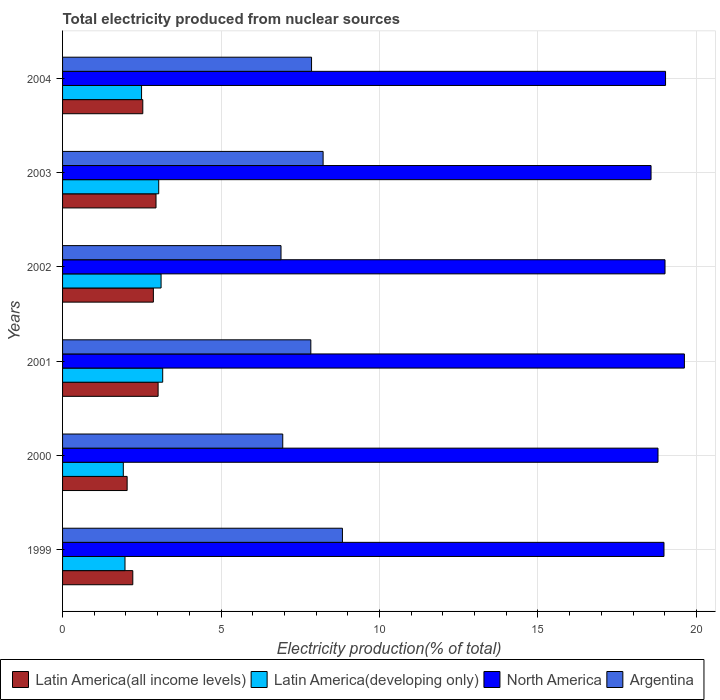How many groups of bars are there?
Make the answer very short. 6. Are the number of bars on each tick of the Y-axis equal?
Give a very brief answer. Yes. How many bars are there on the 5th tick from the bottom?
Make the answer very short. 4. What is the label of the 2nd group of bars from the top?
Your answer should be compact. 2003. In how many cases, is the number of bars for a given year not equal to the number of legend labels?
Offer a very short reply. 0. What is the total electricity produced in Latin America(developing only) in 2004?
Give a very brief answer. 2.49. Across all years, what is the maximum total electricity produced in Latin America(all income levels)?
Ensure brevity in your answer.  3.01. Across all years, what is the minimum total electricity produced in North America?
Offer a terse response. 18.57. What is the total total electricity produced in Latin America(developing only) in the graph?
Keep it short and to the point. 15.68. What is the difference between the total electricity produced in Latin America(all income levels) in 2000 and that in 2003?
Your response must be concise. -0.91. What is the difference between the total electricity produced in Latin America(all income levels) in 2000 and the total electricity produced in Argentina in 1999?
Offer a terse response. -6.79. What is the average total electricity produced in Latin America(all income levels) per year?
Ensure brevity in your answer.  2.6. In the year 2003, what is the difference between the total electricity produced in Argentina and total electricity produced in Latin America(all income levels)?
Provide a short and direct response. 5.27. What is the ratio of the total electricity produced in North America in 1999 to that in 2003?
Your answer should be very brief. 1.02. Is the total electricity produced in North America in 2003 less than that in 2004?
Keep it short and to the point. Yes. What is the difference between the highest and the second highest total electricity produced in Latin America(developing only)?
Your answer should be very brief. 0.05. What is the difference between the highest and the lowest total electricity produced in Argentina?
Your response must be concise. 1.94. In how many years, is the total electricity produced in Argentina greater than the average total electricity produced in Argentina taken over all years?
Make the answer very short. 4. Is the sum of the total electricity produced in North America in 1999 and 2000 greater than the maximum total electricity produced in Argentina across all years?
Ensure brevity in your answer.  Yes. What does the 3rd bar from the top in 2002 represents?
Your answer should be very brief. Latin America(developing only). What does the 2nd bar from the bottom in 2000 represents?
Keep it short and to the point. Latin America(developing only). Is it the case that in every year, the sum of the total electricity produced in Argentina and total electricity produced in Latin America(developing only) is greater than the total electricity produced in North America?
Your response must be concise. No. How many bars are there?
Ensure brevity in your answer.  24. Are all the bars in the graph horizontal?
Your answer should be compact. Yes. How many years are there in the graph?
Make the answer very short. 6. What is the difference between two consecutive major ticks on the X-axis?
Provide a succinct answer. 5. Are the values on the major ticks of X-axis written in scientific E-notation?
Provide a short and direct response. No. Where does the legend appear in the graph?
Provide a short and direct response. Bottom left. How are the legend labels stacked?
Offer a terse response. Horizontal. What is the title of the graph?
Ensure brevity in your answer.  Total electricity produced from nuclear sources. What is the label or title of the X-axis?
Ensure brevity in your answer.  Electricity production(% of total). What is the Electricity production(% of total) in Latin America(all income levels) in 1999?
Provide a succinct answer. 2.22. What is the Electricity production(% of total) in Latin America(developing only) in 1999?
Make the answer very short. 1.97. What is the Electricity production(% of total) of North America in 1999?
Ensure brevity in your answer.  18.98. What is the Electricity production(% of total) in Argentina in 1999?
Your answer should be compact. 8.83. What is the Electricity production(% of total) in Latin America(all income levels) in 2000?
Your answer should be very brief. 2.04. What is the Electricity production(% of total) of Latin America(developing only) in 2000?
Provide a succinct answer. 1.92. What is the Electricity production(% of total) of North America in 2000?
Offer a very short reply. 18.79. What is the Electricity production(% of total) of Argentina in 2000?
Make the answer very short. 6.95. What is the Electricity production(% of total) in Latin America(all income levels) in 2001?
Keep it short and to the point. 3.01. What is the Electricity production(% of total) in Latin America(developing only) in 2001?
Provide a short and direct response. 3.16. What is the Electricity production(% of total) of North America in 2001?
Your response must be concise. 19.62. What is the Electricity production(% of total) of Argentina in 2001?
Your response must be concise. 7.83. What is the Electricity production(% of total) of Latin America(all income levels) in 2002?
Give a very brief answer. 2.87. What is the Electricity production(% of total) in Latin America(developing only) in 2002?
Offer a very short reply. 3.11. What is the Electricity production(% of total) of North America in 2002?
Your response must be concise. 19.01. What is the Electricity production(% of total) of Argentina in 2002?
Offer a terse response. 6.89. What is the Electricity production(% of total) of Latin America(all income levels) in 2003?
Provide a succinct answer. 2.95. What is the Electricity production(% of total) of Latin America(developing only) in 2003?
Ensure brevity in your answer.  3.03. What is the Electricity production(% of total) of North America in 2003?
Offer a very short reply. 18.57. What is the Electricity production(% of total) of Argentina in 2003?
Ensure brevity in your answer.  8.22. What is the Electricity production(% of total) of Latin America(all income levels) in 2004?
Provide a short and direct response. 2.53. What is the Electricity production(% of total) of Latin America(developing only) in 2004?
Ensure brevity in your answer.  2.49. What is the Electricity production(% of total) of North America in 2004?
Ensure brevity in your answer.  19.03. What is the Electricity production(% of total) of Argentina in 2004?
Give a very brief answer. 7.86. Across all years, what is the maximum Electricity production(% of total) in Latin America(all income levels)?
Your answer should be very brief. 3.01. Across all years, what is the maximum Electricity production(% of total) in Latin America(developing only)?
Ensure brevity in your answer.  3.16. Across all years, what is the maximum Electricity production(% of total) in North America?
Your response must be concise. 19.62. Across all years, what is the maximum Electricity production(% of total) of Argentina?
Your response must be concise. 8.83. Across all years, what is the minimum Electricity production(% of total) in Latin America(all income levels)?
Your answer should be very brief. 2.04. Across all years, what is the minimum Electricity production(% of total) of Latin America(developing only)?
Ensure brevity in your answer.  1.92. Across all years, what is the minimum Electricity production(% of total) in North America?
Ensure brevity in your answer.  18.57. Across all years, what is the minimum Electricity production(% of total) in Argentina?
Keep it short and to the point. 6.89. What is the total Electricity production(% of total) in Latin America(all income levels) in the graph?
Make the answer very short. 15.61. What is the total Electricity production(% of total) in Latin America(developing only) in the graph?
Keep it short and to the point. 15.68. What is the total Electricity production(% of total) in North America in the graph?
Offer a terse response. 113.99. What is the total Electricity production(% of total) in Argentina in the graph?
Provide a short and direct response. 46.58. What is the difference between the Electricity production(% of total) of Latin America(all income levels) in 1999 and that in 2000?
Give a very brief answer. 0.18. What is the difference between the Electricity production(% of total) of Latin America(developing only) in 1999 and that in 2000?
Provide a short and direct response. 0.05. What is the difference between the Electricity production(% of total) in North America in 1999 and that in 2000?
Offer a very short reply. 0.19. What is the difference between the Electricity production(% of total) in Argentina in 1999 and that in 2000?
Give a very brief answer. 1.88. What is the difference between the Electricity production(% of total) of Latin America(all income levels) in 1999 and that in 2001?
Keep it short and to the point. -0.8. What is the difference between the Electricity production(% of total) in Latin America(developing only) in 1999 and that in 2001?
Make the answer very short. -1.19. What is the difference between the Electricity production(% of total) of North America in 1999 and that in 2001?
Make the answer very short. -0.64. What is the difference between the Electricity production(% of total) of Argentina in 1999 and that in 2001?
Your answer should be very brief. 1. What is the difference between the Electricity production(% of total) of Latin America(all income levels) in 1999 and that in 2002?
Offer a terse response. -0.65. What is the difference between the Electricity production(% of total) in Latin America(developing only) in 1999 and that in 2002?
Ensure brevity in your answer.  -1.14. What is the difference between the Electricity production(% of total) in North America in 1999 and that in 2002?
Offer a very short reply. -0.03. What is the difference between the Electricity production(% of total) of Argentina in 1999 and that in 2002?
Make the answer very short. 1.94. What is the difference between the Electricity production(% of total) of Latin America(all income levels) in 1999 and that in 2003?
Provide a succinct answer. -0.73. What is the difference between the Electricity production(% of total) in Latin America(developing only) in 1999 and that in 2003?
Make the answer very short. -1.06. What is the difference between the Electricity production(% of total) in North America in 1999 and that in 2003?
Ensure brevity in your answer.  0.41. What is the difference between the Electricity production(% of total) in Argentina in 1999 and that in 2003?
Ensure brevity in your answer.  0.61. What is the difference between the Electricity production(% of total) in Latin America(all income levels) in 1999 and that in 2004?
Ensure brevity in your answer.  -0.32. What is the difference between the Electricity production(% of total) of Latin America(developing only) in 1999 and that in 2004?
Make the answer very short. -0.52. What is the difference between the Electricity production(% of total) of North America in 1999 and that in 2004?
Your response must be concise. -0.05. What is the difference between the Electricity production(% of total) in Argentina in 1999 and that in 2004?
Offer a very short reply. 0.97. What is the difference between the Electricity production(% of total) in Latin America(all income levels) in 2000 and that in 2001?
Offer a terse response. -0.98. What is the difference between the Electricity production(% of total) of Latin America(developing only) in 2000 and that in 2001?
Your answer should be very brief. -1.24. What is the difference between the Electricity production(% of total) in North America in 2000 and that in 2001?
Offer a very short reply. -0.83. What is the difference between the Electricity production(% of total) of Argentina in 2000 and that in 2001?
Your answer should be very brief. -0.89. What is the difference between the Electricity production(% of total) of Latin America(all income levels) in 2000 and that in 2002?
Give a very brief answer. -0.83. What is the difference between the Electricity production(% of total) of Latin America(developing only) in 2000 and that in 2002?
Provide a short and direct response. -1.19. What is the difference between the Electricity production(% of total) in North America in 2000 and that in 2002?
Your answer should be compact. -0.22. What is the difference between the Electricity production(% of total) of Argentina in 2000 and that in 2002?
Ensure brevity in your answer.  0.05. What is the difference between the Electricity production(% of total) of Latin America(all income levels) in 2000 and that in 2003?
Your answer should be compact. -0.91. What is the difference between the Electricity production(% of total) in Latin America(developing only) in 2000 and that in 2003?
Offer a terse response. -1.12. What is the difference between the Electricity production(% of total) of North America in 2000 and that in 2003?
Your response must be concise. 0.22. What is the difference between the Electricity production(% of total) in Argentina in 2000 and that in 2003?
Keep it short and to the point. -1.27. What is the difference between the Electricity production(% of total) of Latin America(all income levels) in 2000 and that in 2004?
Your answer should be very brief. -0.49. What is the difference between the Electricity production(% of total) of Latin America(developing only) in 2000 and that in 2004?
Your response must be concise. -0.58. What is the difference between the Electricity production(% of total) in North America in 2000 and that in 2004?
Your response must be concise. -0.24. What is the difference between the Electricity production(% of total) of Argentina in 2000 and that in 2004?
Ensure brevity in your answer.  -0.91. What is the difference between the Electricity production(% of total) in Latin America(all income levels) in 2001 and that in 2002?
Make the answer very short. 0.15. What is the difference between the Electricity production(% of total) in Latin America(developing only) in 2001 and that in 2002?
Offer a terse response. 0.05. What is the difference between the Electricity production(% of total) of North America in 2001 and that in 2002?
Your response must be concise. 0.61. What is the difference between the Electricity production(% of total) of Argentina in 2001 and that in 2002?
Provide a succinct answer. 0.94. What is the difference between the Electricity production(% of total) in Latin America(all income levels) in 2001 and that in 2003?
Provide a short and direct response. 0.07. What is the difference between the Electricity production(% of total) of Latin America(developing only) in 2001 and that in 2003?
Ensure brevity in your answer.  0.13. What is the difference between the Electricity production(% of total) in North America in 2001 and that in 2003?
Offer a terse response. 1.05. What is the difference between the Electricity production(% of total) of Argentina in 2001 and that in 2003?
Ensure brevity in your answer.  -0.39. What is the difference between the Electricity production(% of total) in Latin America(all income levels) in 2001 and that in 2004?
Your answer should be compact. 0.48. What is the difference between the Electricity production(% of total) of Latin America(developing only) in 2001 and that in 2004?
Provide a short and direct response. 0.67. What is the difference between the Electricity production(% of total) of North America in 2001 and that in 2004?
Make the answer very short. 0.59. What is the difference between the Electricity production(% of total) in Argentina in 2001 and that in 2004?
Your response must be concise. -0.02. What is the difference between the Electricity production(% of total) of Latin America(all income levels) in 2002 and that in 2003?
Offer a very short reply. -0.08. What is the difference between the Electricity production(% of total) in Latin America(developing only) in 2002 and that in 2003?
Make the answer very short. 0.07. What is the difference between the Electricity production(% of total) of North America in 2002 and that in 2003?
Give a very brief answer. 0.44. What is the difference between the Electricity production(% of total) of Argentina in 2002 and that in 2003?
Your answer should be compact. -1.33. What is the difference between the Electricity production(% of total) in Latin America(all income levels) in 2002 and that in 2004?
Give a very brief answer. 0.33. What is the difference between the Electricity production(% of total) in Latin America(developing only) in 2002 and that in 2004?
Your answer should be compact. 0.62. What is the difference between the Electricity production(% of total) in North America in 2002 and that in 2004?
Your answer should be compact. -0.02. What is the difference between the Electricity production(% of total) of Argentina in 2002 and that in 2004?
Your response must be concise. -0.96. What is the difference between the Electricity production(% of total) of Latin America(all income levels) in 2003 and that in 2004?
Ensure brevity in your answer.  0.42. What is the difference between the Electricity production(% of total) of Latin America(developing only) in 2003 and that in 2004?
Provide a succinct answer. 0.54. What is the difference between the Electricity production(% of total) in North America in 2003 and that in 2004?
Provide a short and direct response. -0.46. What is the difference between the Electricity production(% of total) of Argentina in 2003 and that in 2004?
Make the answer very short. 0.37. What is the difference between the Electricity production(% of total) of Latin America(all income levels) in 1999 and the Electricity production(% of total) of Latin America(developing only) in 2000?
Your answer should be very brief. 0.3. What is the difference between the Electricity production(% of total) in Latin America(all income levels) in 1999 and the Electricity production(% of total) in North America in 2000?
Ensure brevity in your answer.  -16.57. What is the difference between the Electricity production(% of total) in Latin America(all income levels) in 1999 and the Electricity production(% of total) in Argentina in 2000?
Make the answer very short. -4.73. What is the difference between the Electricity production(% of total) in Latin America(developing only) in 1999 and the Electricity production(% of total) in North America in 2000?
Make the answer very short. -16.82. What is the difference between the Electricity production(% of total) of Latin America(developing only) in 1999 and the Electricity production(% of total) of Argentina in 2000?
Provide a succinct answer. -4.98. What is the difference between the Electricity production(% of total) of North America in 1999 and the Electricity production(% of total) of Argentina in 2000?
Give a very brief answer. 12.03. What is the difference between the Electricity production(% of total) of Latin America(all income levels) in 1999 and the Electricity production(% of total) of Latin America(developing only) in 2001?
Provide a short and direct response. -0.94. What is the difference between the Electricity production(% of total) in Latin America(all income levels) in 1999 and the Electricity production(% of total) in North America in 2001?
Offer a very short reply. -17.4. What is the difference between the Electricity production(% of total) in Latin America(all income levels) in 1999 and the Electricity production(% of total) in Argentina in 2001?
Your answer should be compact. -5.62. What is the difference between the Electricity production(% of total) in Latin America(developing only) in 1999 and the Electricity production(% of total) in North America in 2001?
Provide a succinct answer. -17.65. What is the difference between the Electricity production(% of total) in Latin America(developing only) in 1999 and the Electricity production(% of total) in Argentina in 2001?
Offer a terse response. -5.86. What is the difference between the Electricity production(% of total) of North America in 1999 and the Electricity production(% of total) of Argentina in 2001?
Provide a short and direct response. 11.14. What is the difference between the Electricity production(% of total) of Latin America(all income levels) in 1999 and the Electricity production(% of total) of Latin America(developing only) in 2002?
Provide a short and direct response. -0.89. What is the difference between the Electricity production(% of total) of Latin America(all income levels) in 1999 and the Electricity production(% of total) of North America in 2002?
Your answer should be compact. -16.79. What is the difference between the Electricity production(% of total) of Latin America(all income levels) in 1999 and the Electricity production(% of total) of Argentina in 2002?
Ensure brevity in your answer.  -4.68. What is the difference between the Electricity production(% of total) in Latin America(developing only) in 1999 and the Electricity production(% of total) in North America in 2002?
Provide a short and direct response. -17.04. What is the difference between the Electricity production(% of total) of Latin America(developing only) in 1999 and the Electricity production(% of total) of Argentina in 2002?
Offer a very short reply. -4.92. What is the difference between the Electricity production(% of total) in North America in 1999 and the Electricity production(% of total) in Argentina in 2002?
Ensure brevity in your answer.  12.08. What is the difference between the Electricity production(% of total) of Latin America(all income levels) in 1999 and the Electricity production(% of total) of Latin America(developing only) in 2003?
Ensure brevity in your answer.  -0.82. What is the difference between the Electricity production(% of total) of Latin America(all income levels) in 1999 and the Electricity production(% of total) of North America in 2003?
Offer a terse response. -16.35. What is the difference between the Electricity production(% of total) in Latin America(all income levels) in 1999 and the Electricity production(% of total) in Argentina in 2003?
Offer a terse response. -6.01. What is the difference between the Electricity production(% of total) in Latin America(developing only) in 1999 and the Electricity production(% of total) in North America in 2003?
Your response must be concise. -16.6. What is the difference between the Electricity production(% of total) in Latin America(developing only) in 1999 and the Electricity production(% of total) in Argentina in 2003?
Your response must be concise. -6.25. What is the difference between the Electricity production(% of total) in North America in 1999 and the Electricity production(% of total) in Argentina in 2003?
Provide a short and direct response. 10.76. What is the difference between the Electricity production(% of total) in Latin America(all income levels) in 1999 and the Electricity production(% of total) in Latin America(developing only) in 2004?
Provide a succinct answer. -0.28. What is the difference between the Electricity production(% of total) in Latin America(all income levels) in 1999 and the Electricity production(% of total) in North America in 2004?
Make the answer very short. -16.81. What is the difference between the Electricity production(% of total) of Latin America(all income levels) in 1999 and the Electricity production(% of total) of Argentina in 2004?
Ensure brevity in your answer.  -5.64. What is the difference between the Electricity production(% of total) in Latin America(developing only) in 1999 and the Electricity production(% of total) in North America in 2004?
Give a very brief answer. -17.06. What is the difference between the Electricity production(% of total) of Latin America(developing only) in 1999 and the Electricity production(% of total) of Argentina in 2004?
Provide a short and direct response. -5.89. What is the difference between the Electricity production(% of total) of North America in 1999 and the Electricity production(% of total) of Argentina in 2004?
Make the answer very short. 11.12. What is the difference between the Electricity production(% of total) of Latin America(all income levels) in 2000 and the Electricity production(% of total) of Latin America(developing only) in 2001?
Offer a terse response. -1.12. What is the difference between the Electricity production(% of total) of Latin America(all income levels) in 2000 and the Electricity production(% of total) of North America in 2001?
Offer a terse response. -17.58. What is the difference between the Electricity production(% of total) in Latin America(all income levels) in 2000 and the Electricity production(% of total) in Argentina in 2001?
Provide a succinct answer. -5.8. What is the difference between the Electricity production(% of total) in Latin America(developing only) in 2000 and the Electricity production(% of total) in North America in 2001?
Your answer should be very brief. -17.7. What is the difference between the Electricity production(% of total) in Latin America(developing only) in 2000 and the Electricity production(% of total) in Argentina in 2001?
Your response must be concise. -5.92. What is the difference between the Electricity production(% of total) in North America in 2000 and the Electricity production(% of total) in Argentina in 2001?
Offer a very short reply. 10.95. What is the difference between the Electricity production(% of total) of Latin America(all income levels) in 2000 and the Electricity production(% of total) of Latin America(developing only) in 2002?
Give a very brief answer. -1.07. What is the difference between the Electricity production(% of total) in Latin America(all income levels) in 2000 and the Electricity production(% of total) in North America in 2002?
Offer a very short reply. -16.97. What is the difference between the Electricity production(% of total) in Latin America(all income levels) in 2000 and the Electricity production(% of total) in Argentina in 2002?
Provide a short and direct response. -4.85. What is the difference between the Electricity production(% of total) of Latin America(developing only) in 2000 and the Electricity production(% of total) of North America in 2002?
Provide a succinct answer. -17.09. What is the difference between the Electricity production(% of total) in Latin America(developing only) in 2000 and the Electricity production(% of total) in Argentina in 2002?
Your answer should be compact. -4.98. What is the difference between the Electricity production(% of total) in North America in 2000 and the Electricity production(% of total) in Argentina in 2002?
Provide a short and direct response. 11.9. What is the difference between the Electricity production(% of total) in Latin America(all income levels) in 2000 and the Electricity production(% of total) in Latin America(developing only) in 2003?
Offer a terse response. -1. What is the difference between the Electricity production(% of total) in Latin America(all income levels) in 2000 and the Electricity production(% of total) in North America in 2003?
Your answer should be compact. -16.53. What is the difference between the Electricity production(% of total) in Latin America(all income levels) in 2000 and the Electricity production(% of total) in Argentina in 2003?
Your answer should be compact. -6.18. What is the difference between the Electricity production(% of total) of Latin America(developing only) in 2000 and the Electricity production(% of total) of North America in 2003?
Keep it short and to the point. -16.65. What is the difference between the Electricity production(% of total) of Latin America(developing only) in 2000 and the Electricity production(% of total) of Argentina in 2003?
Keep it short and to the point. -6.3. What is the difference between the Electricity production(% of total) in North America in 2000 and the Electricity production(% of total) in Argentina in 2003?
Offer a terse response. 10.57. What is the difference between the Electricity production(% of total) of Latin America(all income levels) in 2000 and the Electricity production(% of total) of Latin America(developing only) in 2004?
Keep it short and to the point. -0.45. What is the difference between the Electricity production(% of total) in Latin America(all income levels) in 2000 and the Electricity production(% of total) in North America in 2004?
Make the answer very short. -16.99. What is the difference between the Electricity production(% of total) in Latin America(all income levels) in 2000 and the Electricity production(% of total) in Argentina in 2004?
Provide a succinct answer. -5.82. What is the difference between the Electricity production(% of total) in Latin America(developing only) in 2000 and the Electricity production(% of total) in North America in 2004?
Make the answer very short. -17.11. What is the difference between the Electricity production(% of total) in Latin America(developing only) in 2000 and the Electricity production(% of total) in Argentina in 2004?
Give a very brief answer. -5.94. What is the difference between the Electricity production(% of total) in North America in 2000 and the Electricity production(% of total) in Argentina in 2004?
Make the answer very short. 10.93. What is the difference between the Electricity production(% of total) in Latin America(all income levels) in 2001 and the Electricity production(% of total) in Latin America(developing only) in 2002?
Make the answer very short. -0.09. What is the difference between the Electricity production(% of total) in Latin America(all income levels) in 2001 and the Electricity production(% of total) in North America in 2002?
Make the answer very short. -15.99. What is the difference between the Electricity production(% of total) of Latin America(all income levels) in 2001 and the Electricity production(% of total) of Argentina in 2002?
Offer a very short reply. -3.88. What is the difference between the Electricity production(% of total) in Latin America(developing only) in 2001 and the Electricity production(% of total) in North America in 2002?
Make the answer very short. -15.85. What is the difference between the Electricity production(% of total) of Latin America(developing only) in 2001 and the Electricity production(% of total) of Argentina in 2002?
Make the answer very short. -3.73. What is the difference between the Electricity production(% of total) of North America in 2001 and the Electricity production(% of total) of Argentina in 2002?
Make the answer very short. 12.73. What is the difference between the Electricity production(% of total) in Latin America(all income levels) in 2001 and the Electricity production(% of total) in Latin America(developing only) in 2003?
Ensure brevity in your answer.  -0.02. What is the difference between the Electricity production(% of total) of Latin America(all income levels) in 2001 and the Electricity production(% of total) of North America in 2003?
Keep it short and to the point. -15.55. What is the difference between the Electricity production(% of total) of Latin America(all income levels) in 2001 and the Electricity production(% of total) of Argentina in 2003?
Offer a very short reply. -5.21. What is the difference between the Electricity production(% of total) of Latin America(developing only) in 2001 and the Electricity production(% of total) of North America in 2003?
Make the answer very short. -15.41. What is the difference between the Electricity production(% of total) in Latin America(developing only) in 2001 and the Electricity production(% of total) in Argentina in 2003?
Keep it short and to the point. -5.06. What is the difference between the Electricity production(% of total) of North America in 2001 and the Electricity production(% of total) of Argentina in 2003?
Your answer should be compact. 11.4. What is the difference between the Electricity production(% of total) in Latin America(all income levels) in 2001 and the Electricity production(% of total) in Latin America(developing only) in 2004?
Your answer should be compact. 0.52. What is the difference between the Electricity production(% of total) in Latin America(all income levels) in 2001 and the Electricity production(% of total) in North America in 2004?
Your answer should be compact. -16.01. What is the difference between the Electricity production(% of total) in Latin America(all income levels) in 2001 and the Electricity production(% of total) in Argentina in 2004?
Your answer should be compact. -4.84. What is the difference between the Electricity production(% of total) of Latin America(developing only) in 2001 and the Electricity production(% of total) of North America in 2004?
Offer a very short reply. -15.87. What is the difference between the Electricity production(% of total) of Latin America(developing only) in 2001 and the Electricity production(% of total) of Argentina in 2004?
Your answer should be very brief. -4.7. What is the difference between the Electricity production(% of total) in North America in 2001 and the Electricity production(% of total) in Argentina in 2004?
Keep it short and to the point. 11.76. What is the difference between the Electricity production(% of total) of Latin America(all income levels) in 2002 and the Electricity production(% of total) of Latin America(developing only) in 2003?
Provide a short and direct response. -0.17. What is the difference between the Electricity production(% of total) in Latin America(all income levels) in 2002 and the Electricity production(% of total) in North America in 2003?
Offer a terse response. -15.7. What is the difference between the Electricity production(% of total) of Latin America(all income levels) in 2002 and the Electricity production(% of total) of Argentina in 2003?
Provide a succinct answer. -5.36. What is the difference between the Electricity production(% of total) in Latin America(developing only) in 2002 and the Electricity production(% of total) in North America in 2003?
Your answer should be compact. -15.46. What is the difference between the Electricity production(% of total) of Latin America(developing only) in 2002 and the Electricity production(% of total) of Argentina in 2003?
Your response must be concise. -5.11. What is the difference between the Electricity production(% of total) of North America in 2002 and the Electricity production(% of total) of Argentina in 2003?
Keep it short and to the point. 10.79. What is the difference between the Electricity production(% of total) in Latin America(all income levels) in 2002 and the Electricity production(% of total) in Latin America(developing only) in 2004?
Keep it short and to the point. 0.37. What is the difference between the Electricity production(% of total) in Latin America(all income levels) in 2002 and the Electricity production(% of total) in North America in 2004?
Your response must be concise. -16.16. What is the difference between the Electricity production(% of total) of Latin America(all income levels) in 2002 and the Electricity production(% of total) of Argentina in 2004?
Provide a succinct answer. -4.99. What is the difference between the Electricity production(% of total) in Latin America(developing only) in 2002 and the Electricity production(% of total) in North America in 2004?
Your answer should be very brief. -15.92. What is the difference between the Electricity production(% of total) of Latin America(developing only) in 2002 and the Electricity production(% of total) of Argentina in 2004?
Provide a succinct answer. -4.75. What is the difference between the Electricity production(% of total) of North America in 2002 and the Electricity production(% of total) of Argentina in 2004?
Keep it short and to the point. 11.15. What is the difference between the Electricity production(% of total) of Latin America(all income levels) in 2003 and the Electricity production(% of total) of Latin America(developing only) in 2004?
Offer a terse response. 0.46. What is the difference between the Electricity production(% of total) of Latin America(all income levels) in 2003 and the Electricity production(% of total) of North America in 2004?
Provide a short and direct response. -16.08. What is the difference between the Electricity production(% of total) of Latin America(all income levels) in 2003 and the Electricity production(% of total) of Argentina in 2004?
Your answer should be very brief. -4.91. What is the difference between the Electricity production(% of total) in Latin America(developing only) in 2003 and the Electricity production(% of total) in North America in 2004?
Offer a very short reply. -15.99. What is the difference between the Electricity production(% of total) of Latin America(developing only) in 2003 and the Electricity production(% of total) of Argentina in 2004?
Give a very brief answer. -4.82. What is the difference between the Electricity production(% of total) of North America in 2003 and the Electricity production(% of total) of Argentina in 2004?
Make the answer very short. 10.71. What is the average Electricity production(% of total) of Latin America(all income levels) per year?
Provide a short and direct response. 2.6. What is the average Electricity production(% of total) of Latin America(developing only) per year?
Ensure brevity in your answer.  2.61. What is the average Electricity production(% of total) in North America per year?
Your response must be concise. 19. What is the average Electricity production(% of total) in Argentina per year?
Keep it short and to the point. 7.76. In the year 1999, what is the difference between the Electricity production(% of total) of Latin America(all income levels) and Electricity production(% of total) of Latin America(developing only)?
Ensure brevity in your answer.  0.25. In the year 1999, what is the difference between the Electricity production(% of total) of Latin America(all income levels) and Electricity production(% of total) of North America?
Your answer should be compact. -16.76. In the year 1999, what is the difference between the Electricity production(% of total) of Latin America(all income levels) and Electricity production(% of total) of Argentina?
Your answer should be compact. -6.61. In the year 1999, what is the difference between the Electricity production(% of total) of Latin America(developing only) and Electricity production(% of total) of North America?
Offer a very short reply. -17.01. In the year 1999, what is the difference between the Electricity production(% of total) of Latin America(developing only) and Electricity production(% of total) of Argentina?
Offer a terse response. -6.86. In the year 1999, what is the difference between the Electricity production(% of total) in North America and Electricity production(% of total) in Argentina?
Ensure brevity in your answer.  10.15. In the year 2000, what is the difference between the Electricity production(% of total) in Latin America(all income levels) and Electricity production(% of total) in Latin America(developing only)?
Make the answer very short. 0.12. In the year 2000, what is the difference between the Electricity production(% of total) in Latin America(all income levels) and Electricity production(% of total) in North America?
Keep it short and to the point. -16.75. In the year 2000, what is the difference between the Electricity production(% of total) of Latin America(all income levels) and Electricity production(% of total) of Argentina?
Ensure brevity in your answer.  -4.91. In the year 2000, what is the difference between the Electricity production(% of total) in Latin America(developing only) and Electricity production(% of total) in North America?
Your answer should be very brief. -16.87. In the year 2000, what is the difference between the Electricity production(% of total) in Latin America(developing only) and Electricity production(% of total) in Argentina?
Give a very brief answer. -5.03. In the year 2000, what is the difference between the Electricity production(% of total) in North America and Electricity production(% of total) in Argentina?
Give a very brief answer. 11.84. In the year 2001, what is the difference between the Electricity production(% of total) of Latin America(all income levels) and Electricity production(% of total) of Latin America(developing only)?
Ensure brevity in your answer.  -0.15. In the year 2001, what is the difference between the Electricity production(% of total) of Latin America(all income levels) and Electricity production(% of total) of North America?
Provide a short and direct response. -16.61. In the year 2001, what is the difference between the Electricity production(% of total) in Latin America(all income levels) and Electricity production(% of total) in Argentina?
Provide a short and direct response. -4.82. In the year 2001, what is the difference between the Electricity production(% of total) in Latin America(developing only) and Electricity production(% of total) in North America?
Your response must be concise. -16.46. In the year 2001, what is the difference between the Electricity production(% of total) of Latin America(developing only) and Electricity production(% of total) of Argentina?
Make the answer very short. -4.67. In the year 2001, what is the difference between the Electricity production(% of total) of North America and Electricity production(% of total) of Argentina?
Keep it short and to the point. 11.79. In the year 2002, what is the difference between the Electricity production(% of total) in Latin America(all income levels) and Electricity production(% of total) in Latin America(developing only)?
Ensure brevity in your answer.  -0.24. In the year 2002, what is the difference between the Electricity production(% of total) in Latin America(all income levels) and Electricity production(% of total) in North America?
Offer a terse response. -16.14. In the year 2002, what is the difference between the Electricity production(% of total) in Latin America(all income levels) and Electricity production(% of total) in Argentina?
Your response must be concise. -4.03. In the year 2002, what is the difference between the Electricity production(% of total) of Latin America(developing only) and Electricity production(% of total) of North America?
Give a very brief answer. -15.9. In the year 2002, what is the difference between the Electricity production(% of total) of Latin America(developing only) and Electricity production(% of total) of Argentina?
Make the answer very short. -3.78. In the year 2002, what is the difference between the Electricity production(% of total) in North America and Electricity production(% of total) in Argentina?
Provide a succinct answer. 12.12. In the year 2003, what is the difference between the Electricity production(% of total) of Latin America(all income levels) and Electricity production(% of total) of Latin America(developing only)?
Keep it short and to the point. -0.09. In the year 2003, what is the difference between the Electricity production(% of total) of Latin America(all income levels) and Electricity production(% of total) of North America?
Provide a short and direct response. -15.62. In the year 2003, what is the difference between the Electricity production(% of total) in Latin America(all income levels) and Electricity production(% of total) in Argentina?
Provide a short and direct response. -5.27. In the year 2003, what is the difference between the Electricity production(% of total) of Latin America(developing only) and Electricity production(% of total) of North America?
Provide a succinct answer. -15.53. In the year 2003, what is the difference between the Electricity production(% of total) in Latin America(developing only) and Electricity production(% of total) in Argentina?
Make the answer very short. -5.19. In the year 2003, what is the difference between the Electricity production(% of total) of North America and Electricity production(% of total) of Argentina?
Keep it short and to the point. 10.35. In the year 2004, what is the difference between the Electricity production(% of total) of Latin America(all income levels) and Electricity production(% of total) of Latin America(developing only)?
Offer a terse response. 0.04. In the year 2004, what is the difference between the Electricity production(% of total) in Latin America(all income levels) and Electricity production(% of total) in North America?
Keep it short and to the point. -16.49. In the year 2004, what is the difference between the Electricity production(% of total) of Latin America(all income levels) and Electricity production(% of total) of Argentina?
Your response must be concise. -5.32. In the year 2004, what is the difference between the Electricity production(% of total) in Latin America(developing only) and Electricity production(% of total) in North America?
Offer a terse response. -16.53. In the year 2004, what is the difference between the Electricity production(% of total) of Latin America(developing only) and Electricity production(% of total) of Argentina?
Keep it short and to the point. -5.36. In the year 2004, what is the difference between the Electricity production(% of total) in North America and Electricity production(% of total) in Argentina?
Offer a terse response. 11.17. What is the ratio of the Electricity production(% of total) in Latin America(all income levels) in 1999 to that in 2000?
Your answer should be compact. 1.09. What is the ratio of the Electricity production(% of total) of Latin America(developing only) in 1999 to that in 2000?
Your answer should be very brief. 1.03. What is the ratio of the Electricity production(% of total) in North America in 1999 to that in 2000?
Provide a succinct answer. 1.01. What is the ratio of the Electricity production(% of total) of Argentina in 1999 to that in 2000?
Keep it short and to the point. 1.27. What is the ratio of the Electricity production(% of total) in Latin America(all income levels) in 1999 to that in 2001?
Provide a succinct answer. 0.74. What is the ratio of the Electricity production(% of total) in Latin America(developing only) in 1999 to that in 2001?
Your response must be concise. 0.62. What is the ratio of the Electricity production(% of total) in North America in 1999 to that in 2001?
Ensure brevity in your answer.  0.97. What is the ratio of the Electricity production(% of total) of Argentina in 1999 to that in 2001?
Ensure brevity in your answer.  1.13. What is the ratio of the Electricity production(% of total) in Latin America(all income levels) in 1999 to that in 2002?
Offer a very short reply. 0.77. What is the ratio of the Electricity production(% of total) in Latin America(developing only) in 1999 to that in 2002?
Your response must be concise. 0.63. What is the ratio of the Electricity production(% of total) of Argentina in 1999 to that in 2002?
Provide a short and direct response. 1.28. What is the ratio of the Electricity production(% of total) of Latin America(all income levels) in 1999 to that in 2003?
Your answer should be compact. 0.75. What is the ratio of the Electricity production(% of total) of Latin America(developing only) in 1999 to that in 2003?
Offer a terse response. 0.65. What is the ratio of the Electricity production(% of total) of North America in 1999 to that in 2003?
Provide a short and direct response. 1.02. What is the ratio of the Electricity production(% of total) of Argentina in 1999 to that in 2003?
Provide a short and direct response. 1.07. What is the ratio of the Electricity production(% of total) of Latin America(all income levels) in 1999 to that in 2004?
Provide a short and direct response. 0.88. What is the ratio of the Electricity production(% of total) in Latin America(developing only) in 1999 to that in 2004?
Offer a very short reply. 0.79. What is the ratio of the Electricity production(% of total) of Argentina in 1999 to that in 2004?
Offer a very short reply. 1.12. What is the ratio of the Electricity production(% of total) in Latin America(all income levels) in 2000 to that in 2001?
Offer a very short reply. 0.68. What is the ratio of the Electricity production(% of total) of Latin America(developing only) in 2000 to that in 2001?
Offer a very short reply. 0.61. What is the ratio of the Electricity production(% of total) of North America in 2000 to that in 2001?
Offer a terse response. 0.96. What is the ratio of the Electricity production(% of total) of Argentina in 2000 to that in 2001?
Offer a very short reply. 0.89. What is the ratio of the Electricity production(% of total) of Latin America(all income levels) in 2000 to that in 2002?
Offer a terse response. 0.71. What is the ratio of the Electricity production(% of total) in Latin America(developing only) in 2000 to that in 2002?
Offer a very short reply. 0.62. What is the ratio of the Electricity production(% of total) in North America in 2000 to that in 2002?
Ensure brevity in your answer.  0.99. What is the ratio of the Electricity production(% of total) in Latin America(all income levels) in 2000 to that in 2003?
Give a very brief answer. 0.69. What is the ratio of the Electricity production(% of total) of Latin America(developing only) in 2000 to that in 2003?
Your answer should be compact. 0.63. What is the ratio of the Electricity production(% of total) in North America in 2000 to that in 2003?
Provide a short and direct response. 1.01. What is the ratio of the Electricity production(% of total) in Argentina in 2000 to that in 2003?
Provide a short and direct response. 0.85. What is the ratio of the Electricity production(% of total) in Latin America(all income levels) in 2000 to that in 2004?
Offer a very short reply. 0.8. What is the ratio of the Electricity production(% of total) in Latin America(developing only) in 2000 to that in 2004?
Provide a short and direct response. 0.77. What is the ratio of the Electricity production(% of total) in North America in 2000 to that in 2004?
Ensure brevity in your answer.  0.99. What is the ratio of the Electricity production(% of total) in Argentina in 2000 to that in 2004?
Provide a short and direct response. 0.88. What is the ratio of the Electricity production(% of total) of Latin America(all income levels) in 2001 to that in 2002?
Your answer should be compact. 1.05. What is the ratio of the Electricity production(% of total) in Latin America(developing only) in 2001 to that in 2002?
Your answer should be very brief. 1.02. What is the ratio of the Electricity production(% of total) of North America in 2001 to that in 2002?
Offer a terse response. 1.03. What is the ratio of the Electricity production(% of total) in Argentina in 2001 to that in 2002?
Your answer should be compact. 1.14. What is the ratio of the Electricity production(% of total) in Latin America(all income levels) in 2001 to that in 2003?
Your response must be concise. 1.02. What is the ratio of the Electricity production(% of total) in Latin America(developing only) in 2001 to that in 2003?
Provide a short and direct response. 1.04. What is the ratio of the Electricity production(% of total) in North America in 2001 to that in 2003?
Provide a succinct answer. 1.06. What is the ratio of the Electricity production(% of total) in Argentina in 2001 to that in 2003?
Make the answer very short. 0.95. What is the ratio of the Electricity production(% of total) in Latin America(all income levels) in 2001 to that in 2004?
Your answer should be compact. 1.19. What is the ratio of the Electricity production(% of total) in Latin America(developing only) in 2001 to that in 2004?
Offer a terse response. 1.27. What is the ratio of the Electricity production(% of total) of North America in 2001 to that in 2004?
Your answer should be compact. 1.03. What is the ratio of the Electricity production(% of total) of Latin America(all income levels) in 2002 to that in 2003?
Offer a very short reply. 0.97. What is the ratio of the Electricity production(% of total) of Latin America(developing only) in 2002 to that in 2003?
Give a very brief answer. 1.02. What is the ratio of the Electricity production(% of total) of North America in 2002 to that in 2003?
Offer a terse response. 1.02. What is the ratio of the Electricity production(% of total) of Argentina in 2002 to that in 2003?
Give a very brief answer. 0.84. What is the ratio of the Electricity production(% of total) of Latin America(all income levels) in 2002 to that in 2004?
Ensure brevity in your answer.  1.13. What is the ratio of the Electricity production(% of total) of Latin America(developing only) in 2002 to that in 2004?
Provide a short and direct response. 1.25. What is the ratio of the Electricity production(% of total) in North America in 2002 to that in 2004?
Offer a terse response. 1. What is the ratio of the Electricity production(% of total) of Argentina in 2002 to that in 2004?
Make the answer very short. 0.88. What is the ratio of the Electricity production(% of total) of Latin America(all income levels) in 2003 to that in 2004?
Give a very brief answer. 1.16. What is the ratio of the Electricity production(% of total) in Latin America(developing only) in 2003 to that in 2004?
Your response must be concise. 1.22. What is the ratio of the Electricity production(% of total) in North America in 2003 to that in 2004?
Keep it short and to the point. 0.98. What is the ratio of the Electricity production(% of total) of Argentina in 2003 to that in 2004?
Offer a very short reply. 1.05. What is the difference between the highest and the second highest Electricity production(% of total) of Latin America(all income levels)?
Your response must be concise. 0.07. What is the difference between the highest and the second highest Electricity production(% of total) of Latin America(developing only)?
Give a very brief answer. 0.05. What is the difference between the highest and the second highest Electricity production(% of total) of North America?
Keep it short and to the point. 0.59. What is the difference between the highest and the second highest Electricity production(% of total) in Argentina?
Offer a terse response. 0.61. What is the difference between the highest and the lowest Electricity production(% of total) in Latin America(developing only)?
Your answer should be compact. 1.24. What is the difference between the highest and the lowest Electricity production(% of total) in North America?
Provide a short and direct response. 1.05. What is the difference between the highest and the lowest Electricity production(% of total) of Argentina?
Your answer should be very brief. 1.94. 